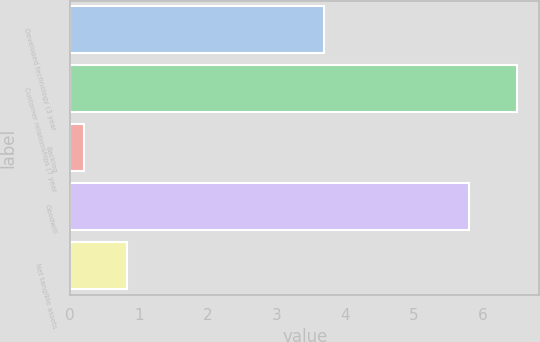<chart> <loc_0><loc_0><loc_500><loc_500><bar_chart><fcel>Developed technology (3 year<fcel>Customer relationships (7 year<fcel>Backlog<fcel>Goodwill<fcel>Net tangible assets<nl><fcel>3.7<fcel>6.5<fcel>0.2<fcel>5.8<fcel>0.83<nl></chart> 